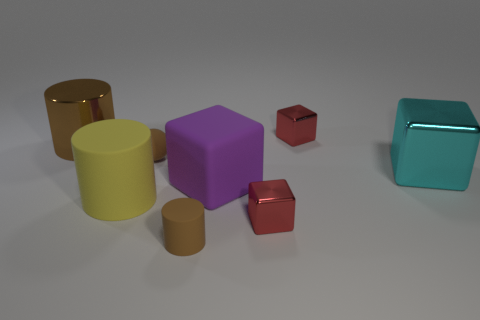Subtract 1 cylinders. How many cylinders are left? 2 Subtract all cyan cubes. How many cubes are left? 3 Subtract all rubber blocks. How many blocks are left? 3 Add 1 tiny red shiny things. How many objects exist? 9 Subtract all brown blocks. Subtract all yellow cylinders. How many blocks are left? 4 Subtract all balls. How many objects are left? 7 Add 8 small red objects. How many small red objects are left? 10 Add 1 purple matte things. How many purple matte things exist? 2 Subtract 0 green cubes. How many objects are left? 8 Subtract all green blocks. Subtract all tiny balls. How many objects are left? 7 